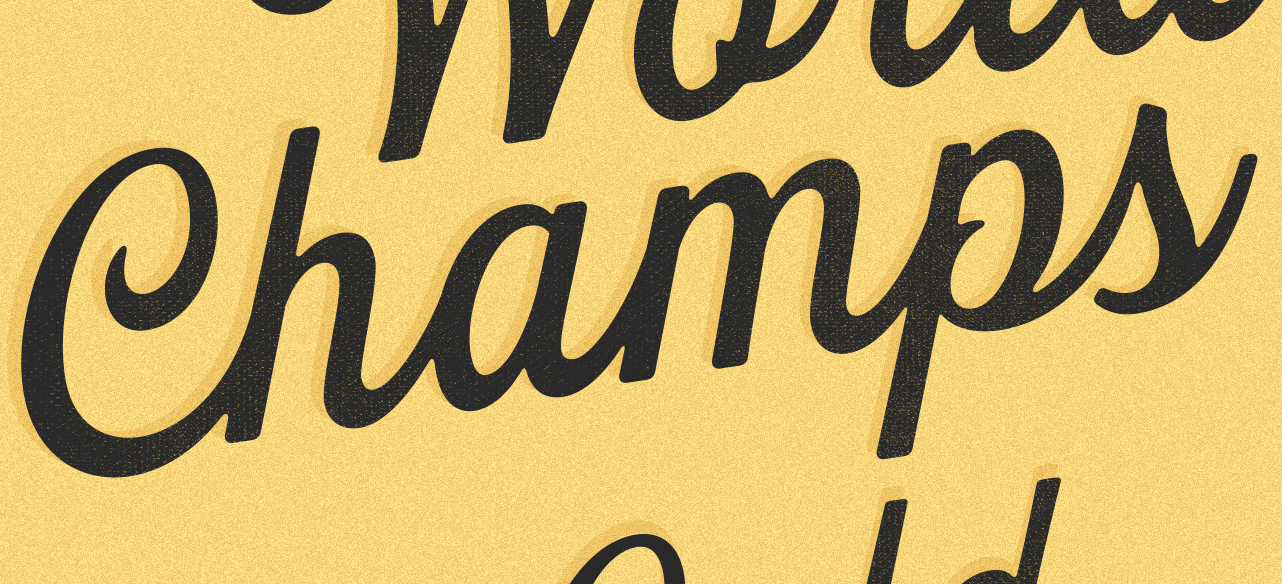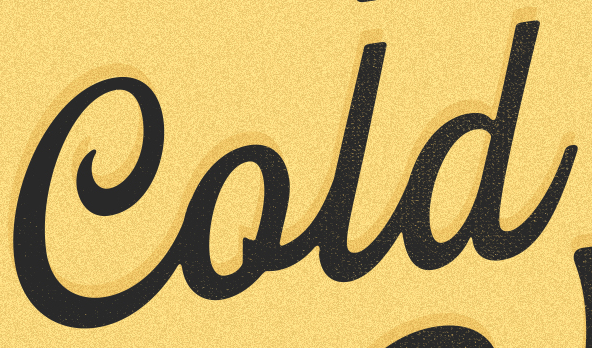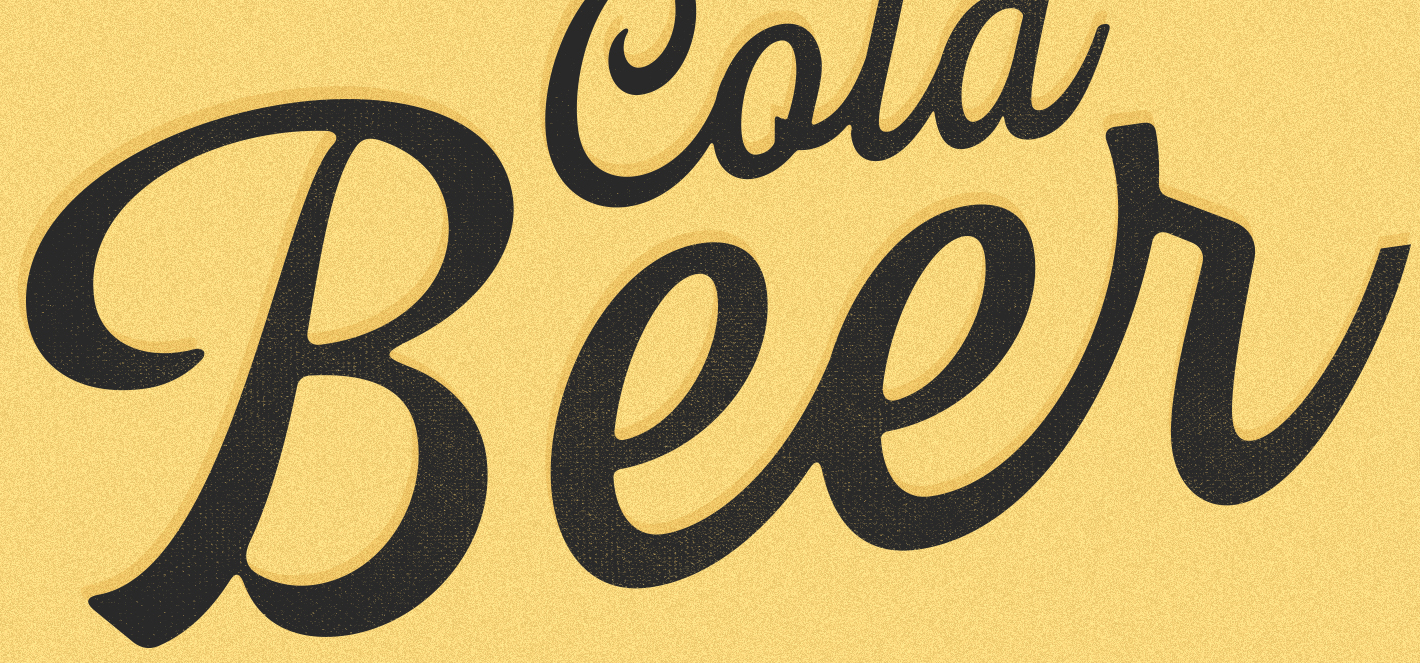Read the text from these images in sequence, separated by a semicolon. Champs; Cold; Beer 